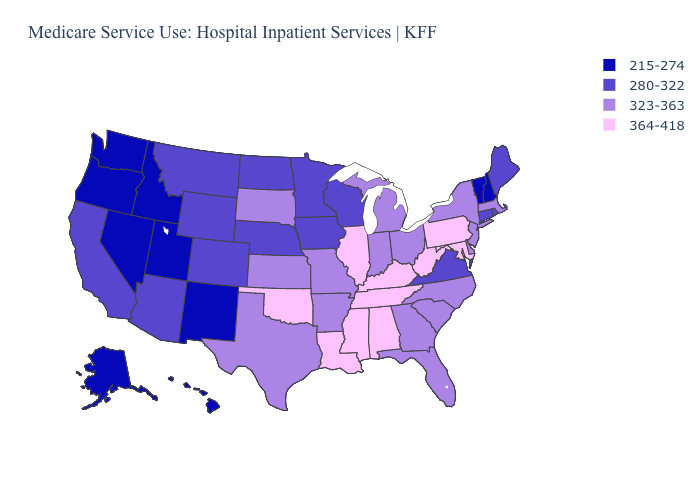What is the value of Illinois?
Quick response, please. 364-418. What is the value of New Hampshire?
Answer briefly. 215-274. Name the states that have a value in the range 280-322?
Write a very short answer. Arizona, California, Colorado, Connecticut, Iowa, Maine, Minnesota, Montana, Nebraska, North Dakota, Rhode Island, Virginia, Wisconsin, Wyoming. Among the states that border Texas , which have the lowest value?
Short answer required. New Mexico. Name the states that have a value in the range 280-322?
Give a very brief answer. Arizona, California, Colorado, Connecticut, Iowa, Maine, Minnesota, Montana, Nebraska, North Dakota, Rhode Island, Virginia, Wisconsin, Wyoming. Among the states that border Utah , which have the lowest value?
Keep it brief. Idaho, Nevada, New Mexico. Which states have the lowest value in the USA?
Write a very short answer. Alaska, Hawaii, Idaho, Nevada, New Hampshire, New Mexico, Oregon, Utah, Vermont, Washington. Among the states that border Wyoming , which have the lowest value?
Short answer required. Idaho, Utah. Among the states that border Mississippi , which have the lowest value?
Answer briefly. Arkansas. What is the lowest value in the West?
Short answer required. 215-274. Does Delaware have the lowest value in the South?
Give a very brief answer. No. Among the states that border Wyoming , does South Dakota have the highest value?
Be succinct. Yes. Name the states that have a value in the range 364-418?
Answer briefly. Alabama, Illinois, Kentucky, Louisiana, Maryland, Mississippi, Oklahoma, Pennsylvania, Tennessee, West Virginia. Name the states that have a value in the range 364-418?
Quick response, please. Alabama, Illinois, Kentucky, Louisiana, Maryland, Mississippi, Oklahoma, Pennsylvania, Tennessee, West Virginia. 